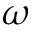Convert formula to latex. <formula><loc_0><loc_0><loc_500><loc_500>\omega</formula> 